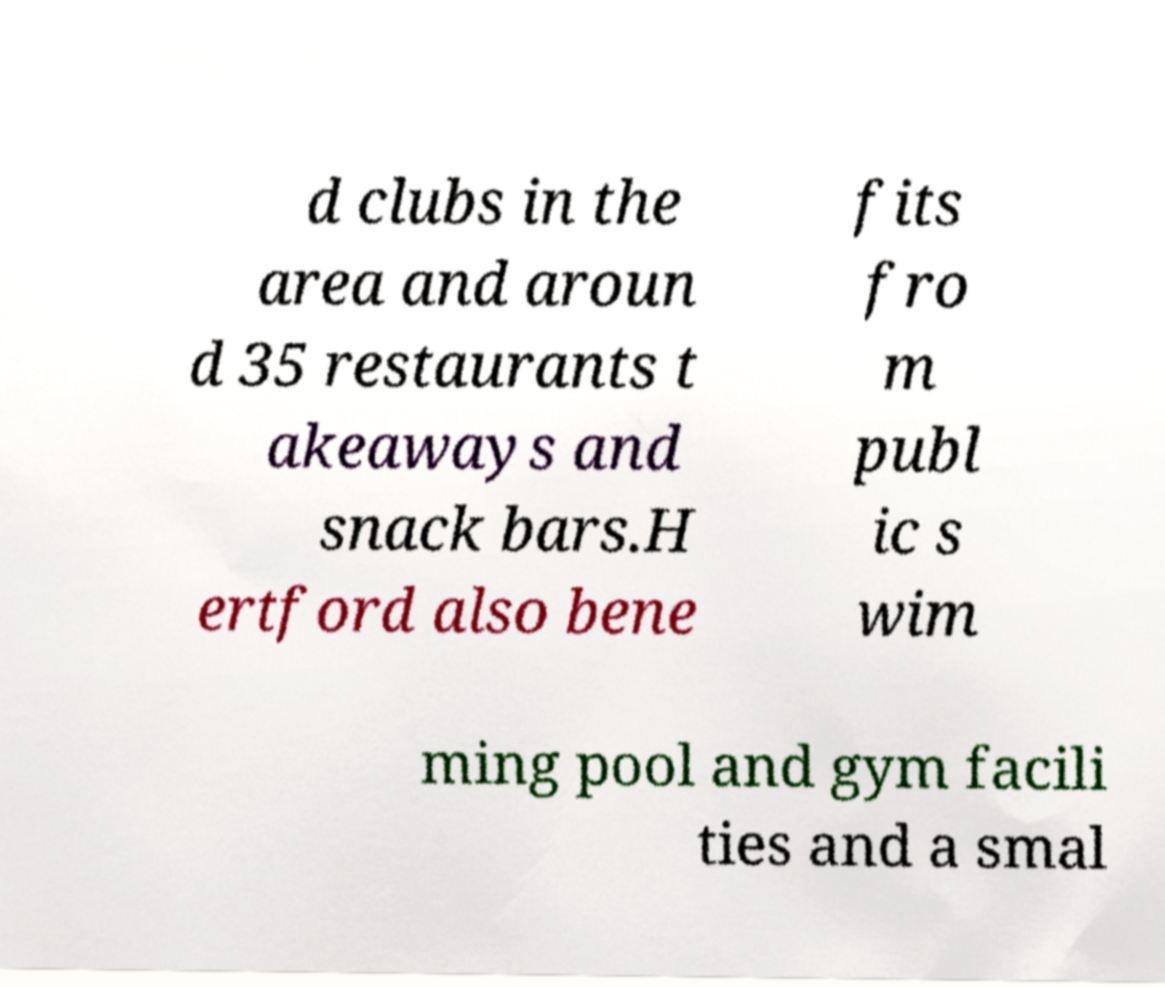Please read and relay the text visible in this image. What does it say? d clubs in the area and aroun d 35 restaurants t akeaways and snack bars.H ertford also bene fits fro m publ ic s wim ming pool and gym facili ties and a smal 